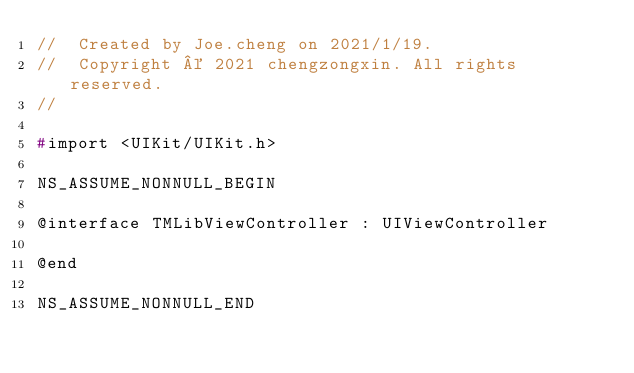<code> <loc_0><loc_0><loc_500><loc_500><_C_>//  Created by Joe.cheng on 2021/1/19.
//  Copyright © 2021 chengzongxin. All rights reserved.
//

#import <UIKit/UIKit.h>

NS_ASSUME_NONNULL_BEGIN

@interface TMLibViewController : UIViewController

@end

NS_ASSUME_NONNULL_END
</code> 